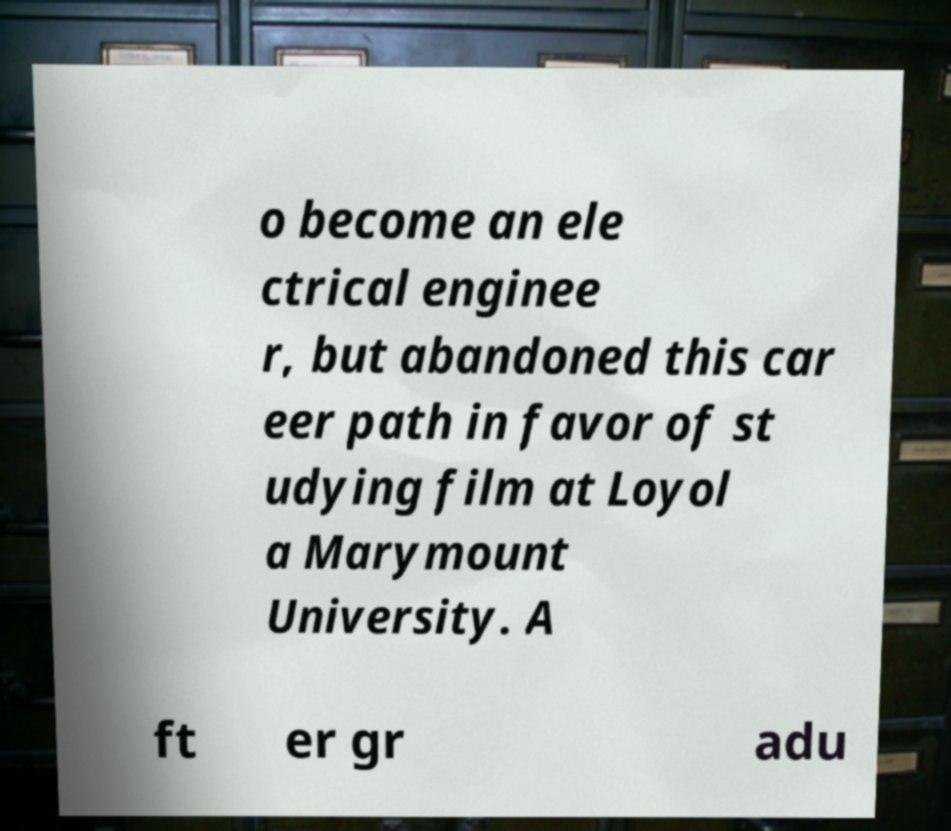What messages or text are displayed in this image? I need them in a readable, typed format. o become an ele ctrical enginee r, but abandoned this car eer path in favor of st udying film at Loyol a Marymount University. A ft er gr adu 